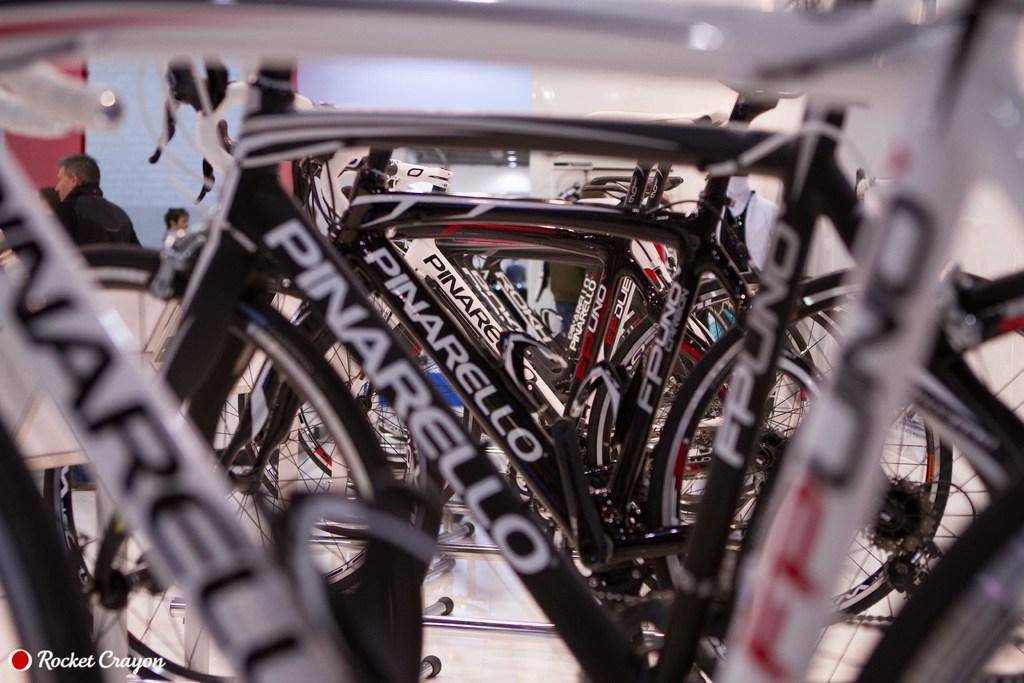In one or two sentences, can you explain what this image depicts? In the image there are plenty of cycles kept one beside another in a row and on the left side some people are gathered and in the background there is pink wall. 